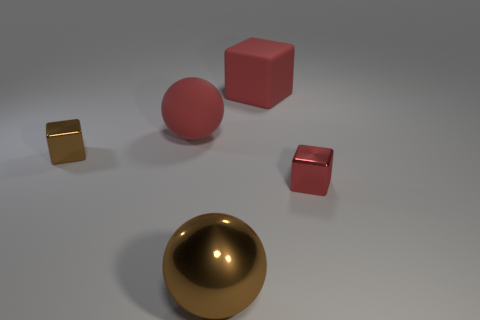What is the color of the tiny metal thing that is behind the small metallic block that is on the right side of the red matte ball?
Ensure brevity in your answer.  Brown. Is the color of the rubber cube the same as the rubber sphere?
Your answer should be very brief. Yes. What is the material of the red block that is behind the tiny metal block behind the tiny red metal cube?
Offer a very short reply. Rubber. There is another red thing that is the same shape as the red shiny object; what is it made of?
Give a very brief answer. Rubber. There is a red object in front of the metal block that is behind the red shiny thing; is there a small red cube to the left of it?
Provide a short and direct response. No. What number of other objects are there of the same color as the matte ball?
Your response must be concise. 2. What number of tiny objects are to the left of the metallic ball and in front of the brown metallic cube?
Offer a terse response. 0. What is the shape of the tiny brown metal object?
Offer a very short reply. Cube. What number of other objects are the same material as the brown block?
Make the answer very short. 2. What is the color of the big rubber object that is to the left of the red thing behind the rubber object in front of the red matte cube?
Provide a succinct answer. Red. 